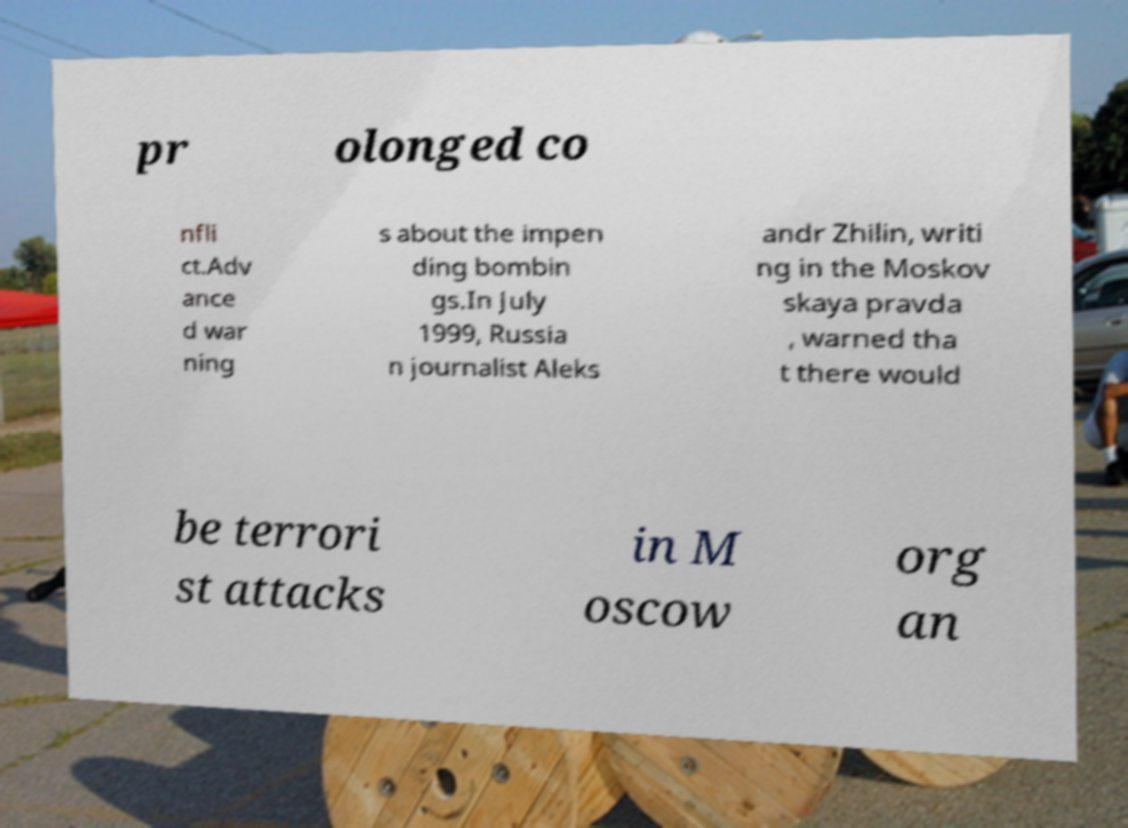Could you extract and type out the text from this image? pr olonged co nfli ct.Adv ance d war ning s about the impen ding bombin gs.In July 1999, Russia n journalist Aleks andr Zhilin, writi ng in the Moskov skaya pravda , warned tha t there would be terrori st attacks in M oscow org an 